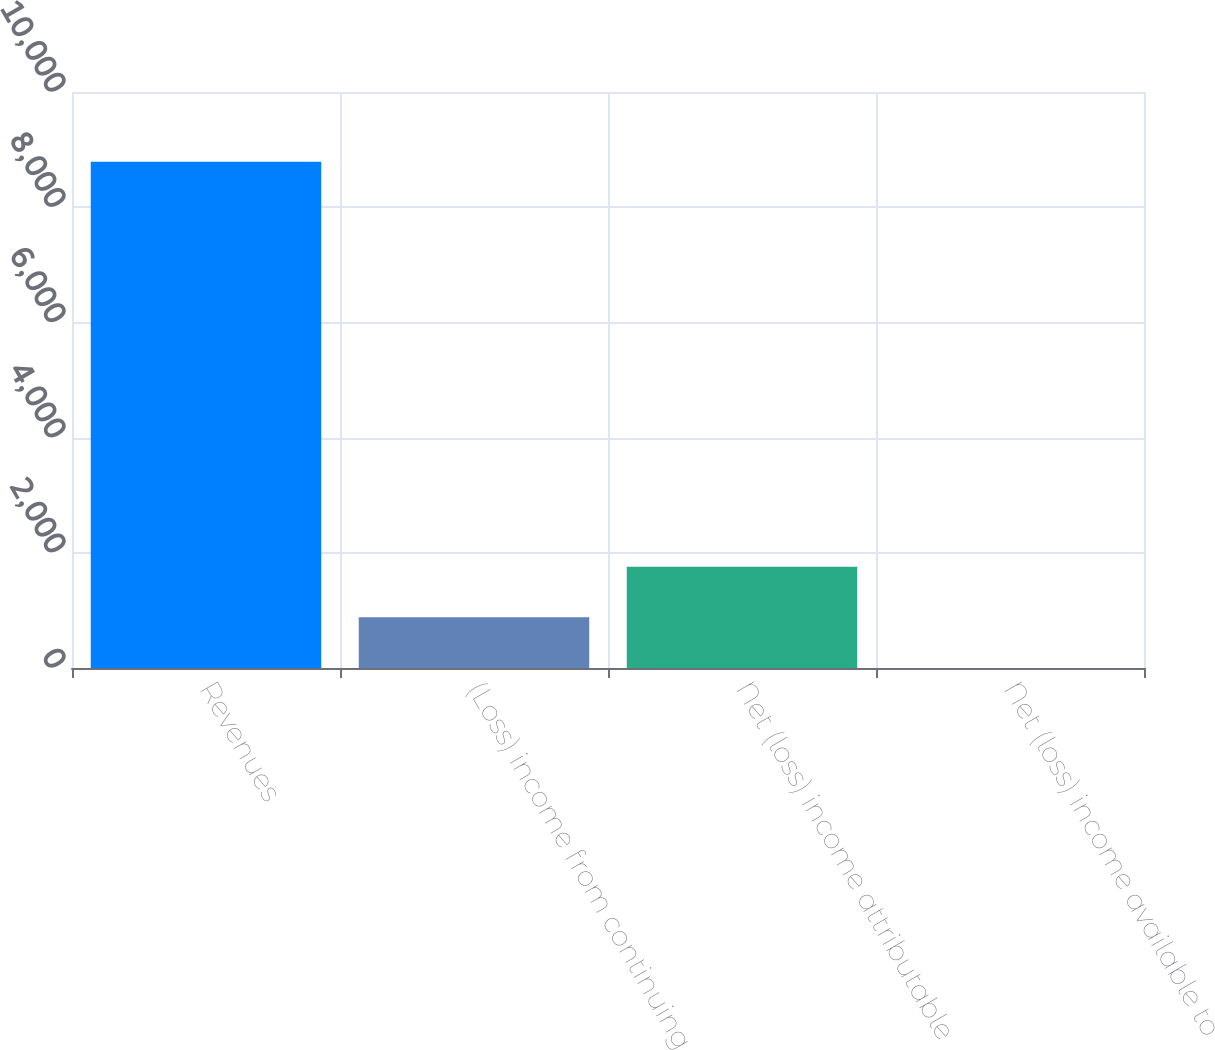Convert chart. <chart><loc_0><loc_0><loc_500><loc_500><bar_chart><fcel>Revenues<fcel>(Loss) income from continuing<fcel>Net (loss) income attributable<fcel>Net (loss) income available to<nl><fcel>8789<fcel>879.68<fcel>1758.49<fcel>0.87<nl></chart> 